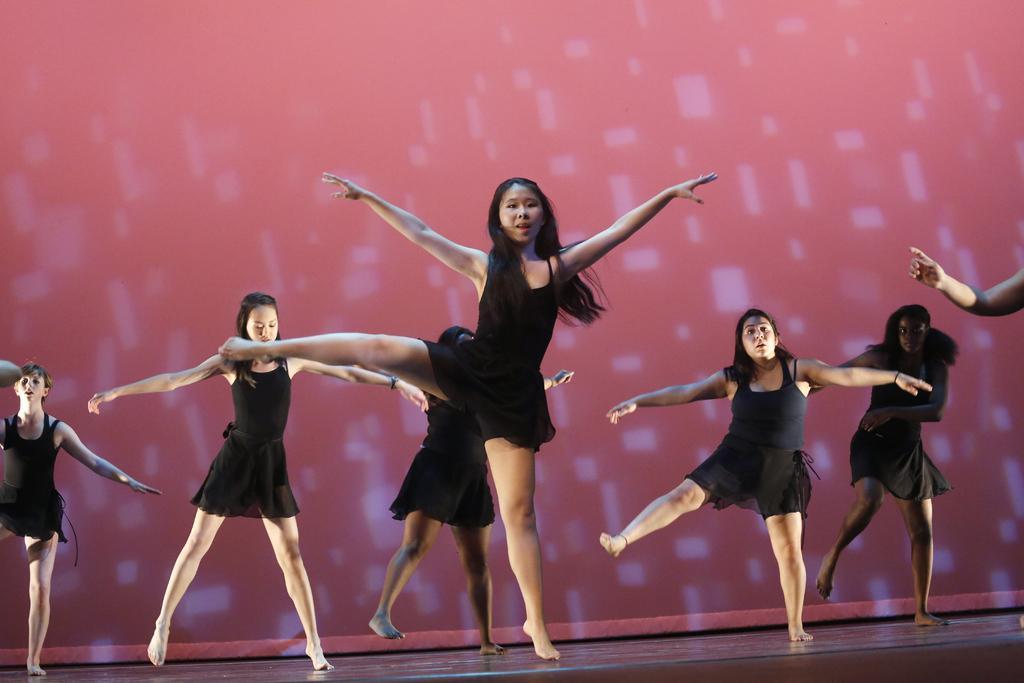Please provide a concise description of this image. In this image few women are dancing on the stage. They are wearing black dress. Behind them there is a wall. 